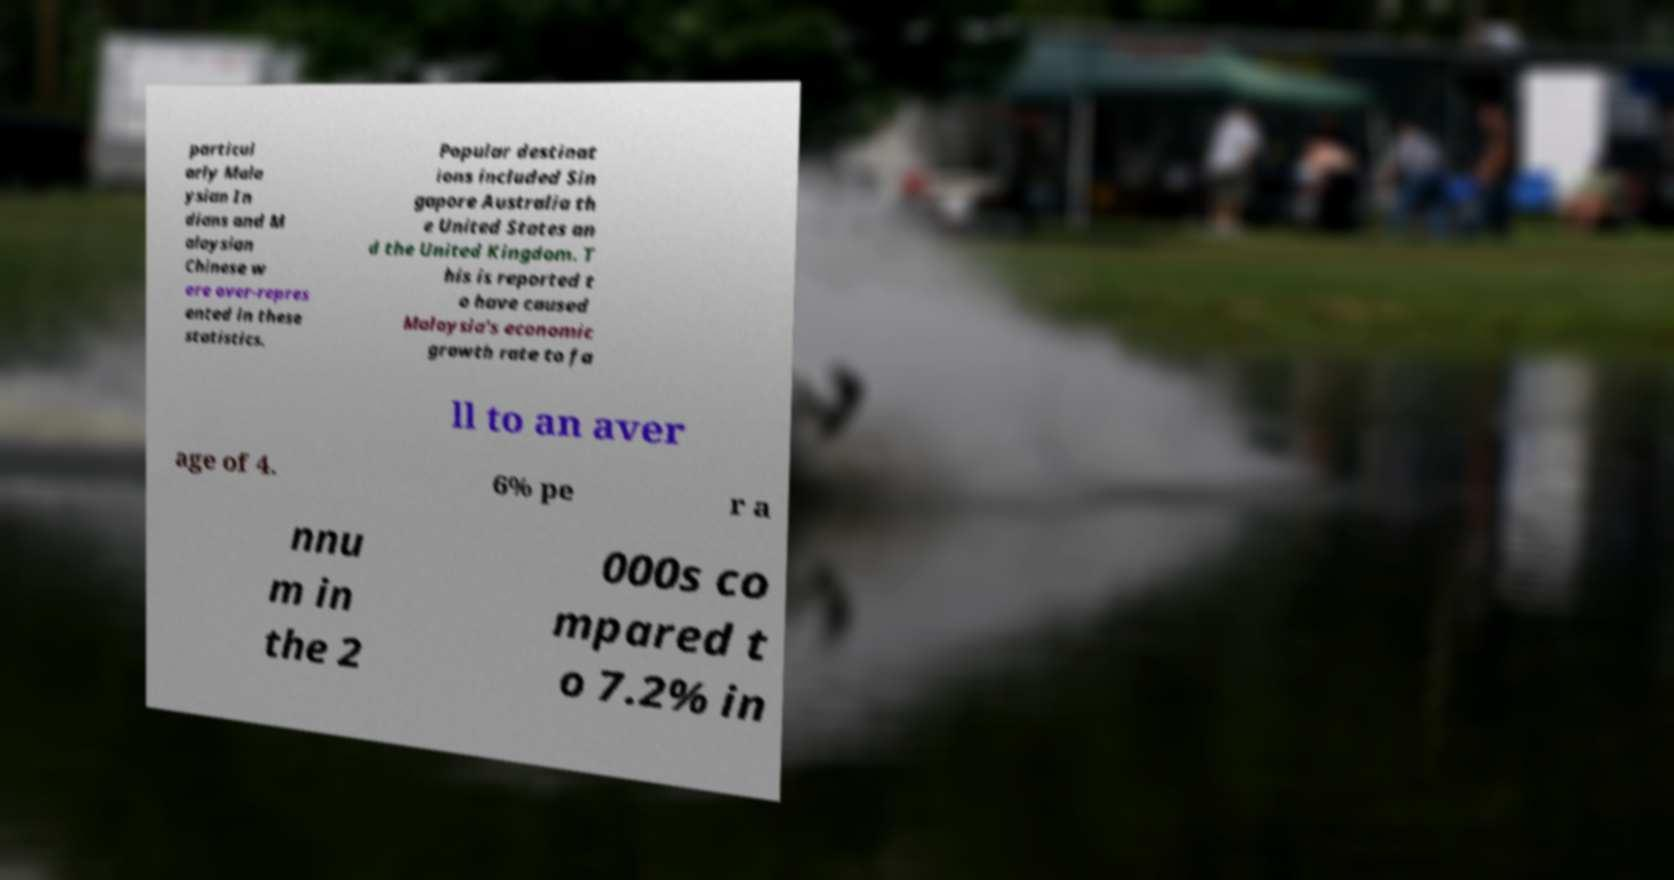What messages or text are displayed in this image? I need them in a readable, typed format. particul arly Mala ysian In dians and M alaysian Chinese w ere over-repres ented in these statistics. Popular destinat ions included Sin gapore Australia th e United States an d the United Kingdom. T his is reported t o have caused Malaysia's economic growth rate to fa ll to an aver age of 4. 6% pe r a nnu m in the 2 000s co mpared t o 7.2% in 